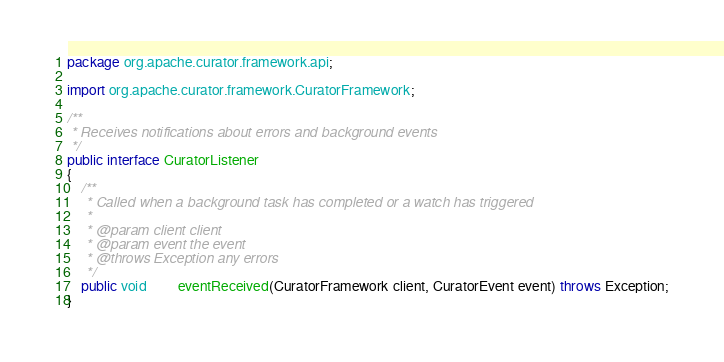<code> <loc_0><loc_0><loc_500><loc_500><_Java_>package org.apache.curator.framework.api;

import org.apache.curator.framework.CuratorFramework;

/**
 * Receives notifications about errors and background events
 */
public interface CuratorListener
{
    /**
     * Called when a background task has completed or a watch has triggered
     *
     * @param client client
     * @param event the event
     * @throws Exception any errors
     */
    public void         eventReceived(CuratorFramework client, CuratorEvent event) throws Exception;
}
</code> 